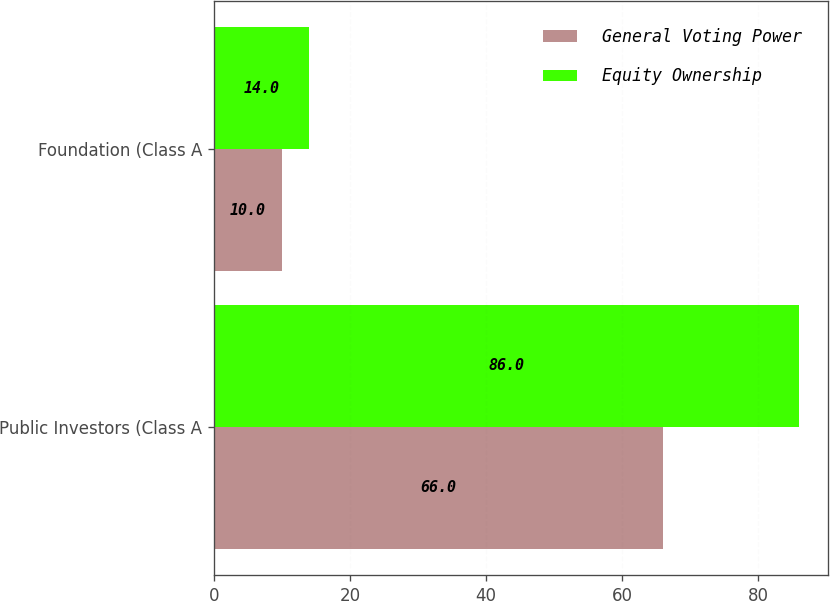Convert chart. <chart><loc_0><loc_0><loc_500><loc_500><stacked_bar_chart><ecel><fcel>Public Investors (Class A<fcel>Foundation (Class A<nl><fcel>General Voting Power<fcel>66<fcel>10<nl><fcel>Equity Ownership<fcel>86<fcel>14<nl></chart> 